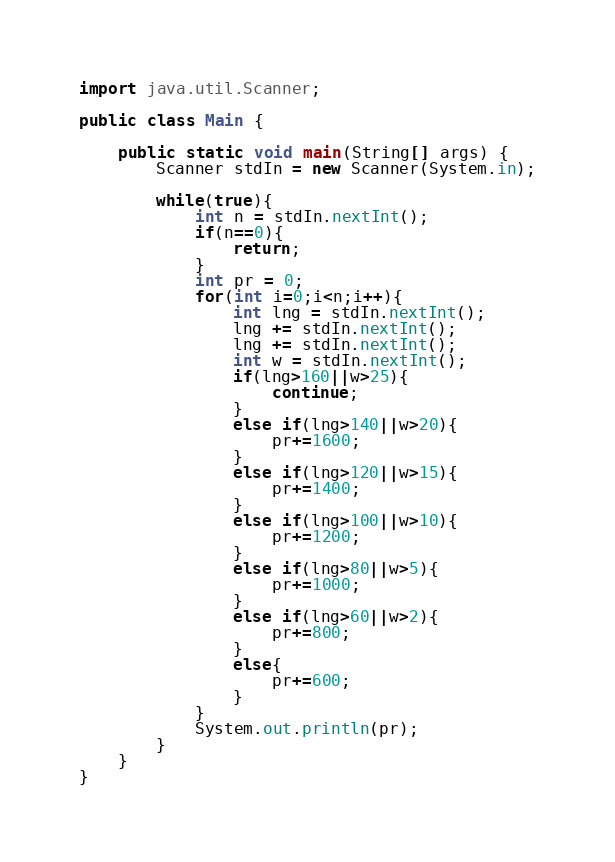Convert code to text. <code><loc_0><loc_0><loc_500><loc_500><_Java_>import java.util.Scanner;

public class Main {

	public static void main(String[] args) {
		Scanner stdIn = new Scanner(System.in);
		
		while(true){
			int n = stdIn.nextInt();
			if(n==0){
				return;
			}
			int pr = 0;
			for(int i=0;i<n;i++){
				int lng = stdIn.nextInt();
				lng += stdIn.nextInt();
				lng += stdIn.nextInt();
				int w = stdIn.nextInt();
				if(lng>160||w>25){
					continue;
				}
				else if(lng>140||w>20){
					pr+=1600;
				}
				else if(lng>120||w>15){
					pr+=1400;
				}
				else if(lng>100||w>10){
					pr+=1200;
				}
				else if(lng>80||w>5){
					pr+=1000;
				}
				else if(lng>60||w>2){
					pr+=800;
				}
				else{
					pr+=600;
				}
			}
			System.out.println(pr);
		}
	}
}</code> 